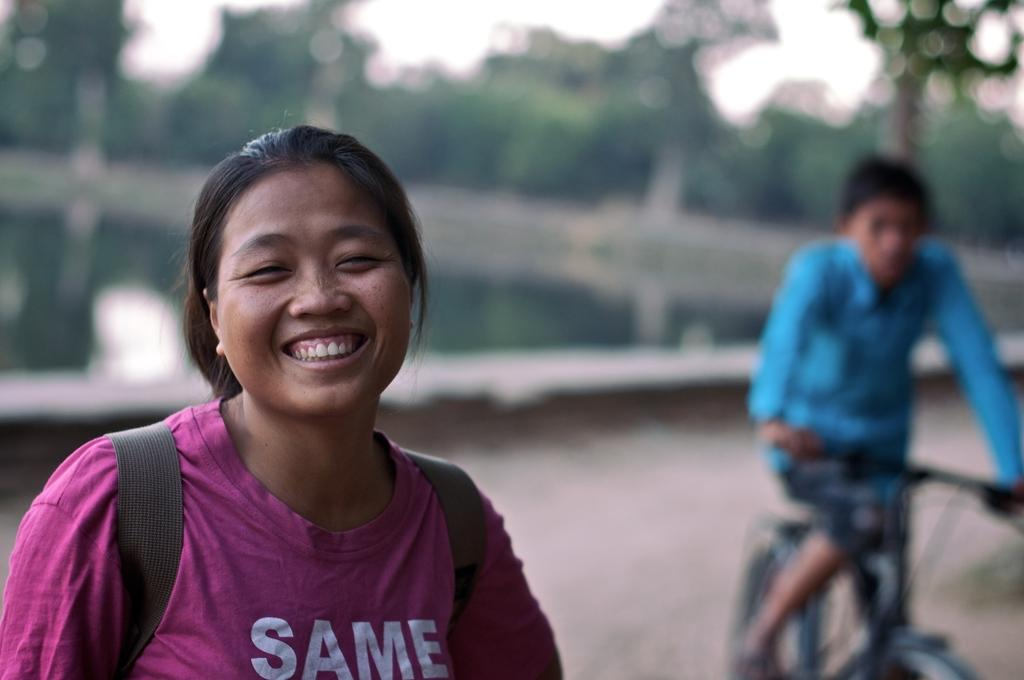Who is the main subject on the left side of the image? There is a woman on the left side of the image. What is the woman doing in the image? The woman is smiling in the image. Who is the other person in the image? There is a boy in the image. What is the boy doing in the image? The boy is on a bicycle in the image. Where is the boy located in the image? The boy is on the right side of the image. What type of beast can be seen in the image? There is no beast present in the image. Who is the grandmother in the image? There is no mention of a grandmother in the image. 